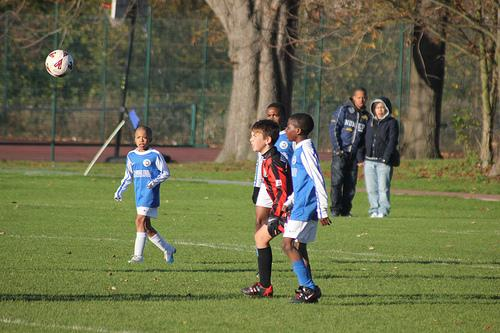Can you count the number of spectators and describe their clothing? There are two spectators, a man and a woman, both wearing black jackets. Identify the primary activity depicted in the image. Kids are playing soccer on a field. What type of field are the kids playing on, and what season does it appear to be? The kids are playing on a green grass soccer field, and it appears to be fall season. What is unique about the footwear in the image? The black and red soccer shoes are notable in the image. What is the color and pattern of the soccer ball in the picture? The soccer ball is red and white. Describe any shadow that is visible in the image. There is a shadow on the soccer field, likely caused by the sun and trees around. How many kids are engaged in soccer, and what are the colors of their jerseys? Four kids are playing soccer, wearing blue and white, and red and black jerseys. How does the image make you feel and why? The image evokes feelings of excitement and nostalgia, as it captures a fun and active moment of kids playing soccer in the outdoors. Please provide a brief description of the background objects. A fence, tree trunks, basketball court and basketball hoop are visible in the background. Please mention any instances of object interaction in the image. A kid in a red and black jersey is interacting with the red and white soccer ball. Identify the hot air balloon floating in the distance behind the soccer field, with vibrant colors and patterns adorning its surface. It must be a surprising sight for the players and spectators alike. No, it's not mentioned in the image. Observe the picture and explain the activity of the couple at the sidelines. Watching the soccer match Explain the activity that is occurring in the picture. Kids are playing soccer, and some spectators are watching from the sidelines What is the color of the soccer ball in the air? Red and white What season is depicted in the picture? Choose among the following: Summer, Winter, Spring, or Fall. Fall Capture the essence of the picture in a single sentence by describing both the foreground and background elements. Kids engage in an exciting soccer match as spectators watch from the sidelines, with a basketball court and a fence in the background. Elaborate on the elements related to the sport of basketball that are visible in the picture. Basketball hoop, basketball court in the background What part of the basketball hoop is visible in the picture? Choose from the options: Rim, Backboard, or Pole. Rim Detect if there are any events happening in the picture. A soccer match is taking place Look for any text present on the clothes of the boys playing soccer and identify the content. No text visible What sport are the kids playing in the picture? Select from the options below: Soccer, Baseball, Basketball, or Rugby. Soccer Read the text in the picture and provide the words or phrases present in the image. No text available in the image What does the woman on the sidelines have on her head? A hood What type of socks is the boy in a blue and white shirt wearing? Choose one of the following options: White socks, Blue socks, or Green socks. White socks Identify the color of the trousers the man watching from the sidelines is wearing. Cannot be determined Is there a soccer match or a basketball match going on in the picture? Soccer match What kind of shoes are the kids wearing in the picture? black and red soccer shoes Describe the scene of the picture in an informal tone that includes the background elements like the basketball hoop. A bunch of kids are having a blast playing soccer, while in the background you can see a basketball hoop and a fence. There's even a tall tree! Describe the clothing worn by the boy in the long-sleeved blue jersey standing away from the group. Long-sleeved blue and white shirt, white socks Write a caption for the picture in a poetic style. Amidst autumn's embrace, youthful passion flourishes on the green stage, as spectators marvel at the dance of soccer and life. 